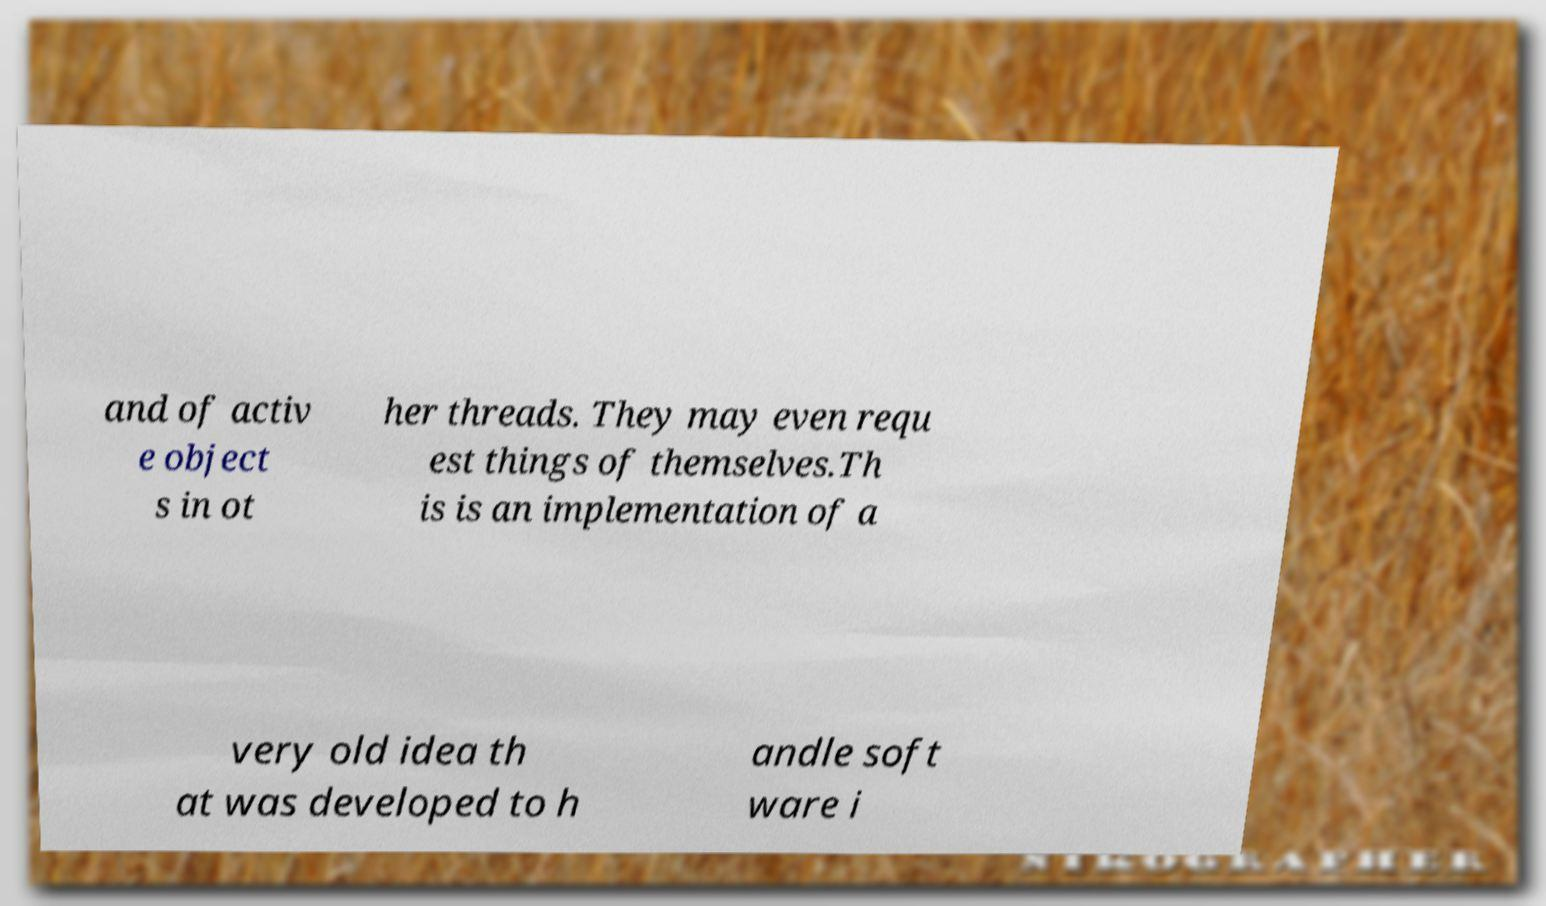Could you extract and type out the text from this image? and of activ e object s in ot her threads. They may even requ est things of themselves.Th is is an implementation of a very old idea th at was developed to h andle soft ware i 